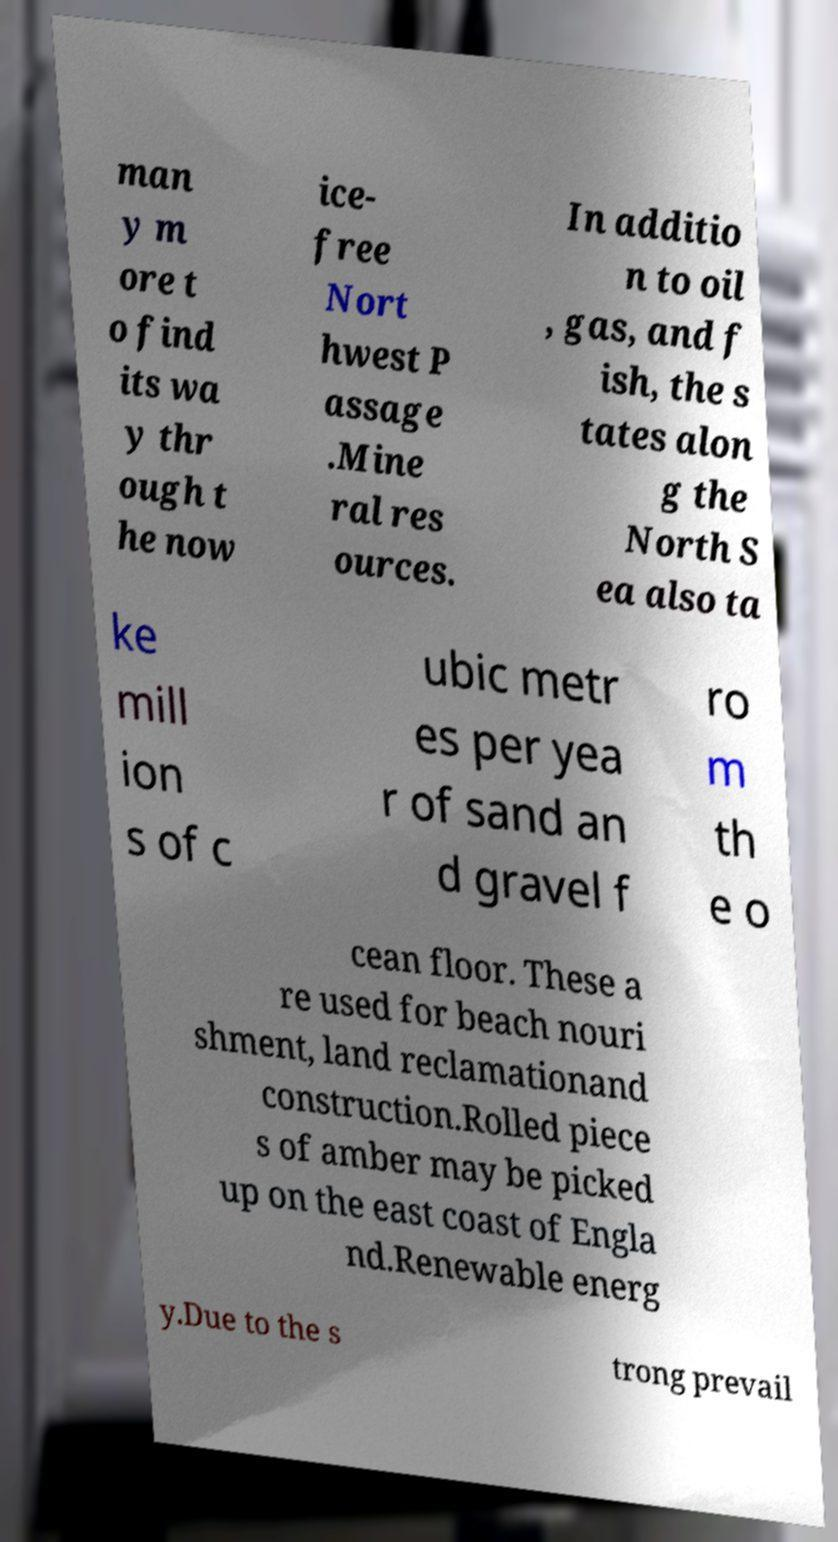Could you assist in decoding the text presented in this image and type it out clearly? man y m ore t o find its wa y thr ough t he now ice- free Nort hwest P assage .Mine ral res ources. In additio n to oil , gas, and f ish, the s tates alon g the North S ea also ta ke mill ion s of c ubic metr es per yea r of sand an d gravel f ro m th e o cean floor. These a re used for beach nouri shment, land reclamationand construction.Rolled piece s of amber may be picked up on the east coast of Engla nd.Renewable energ y.Due to the s trong prevail 